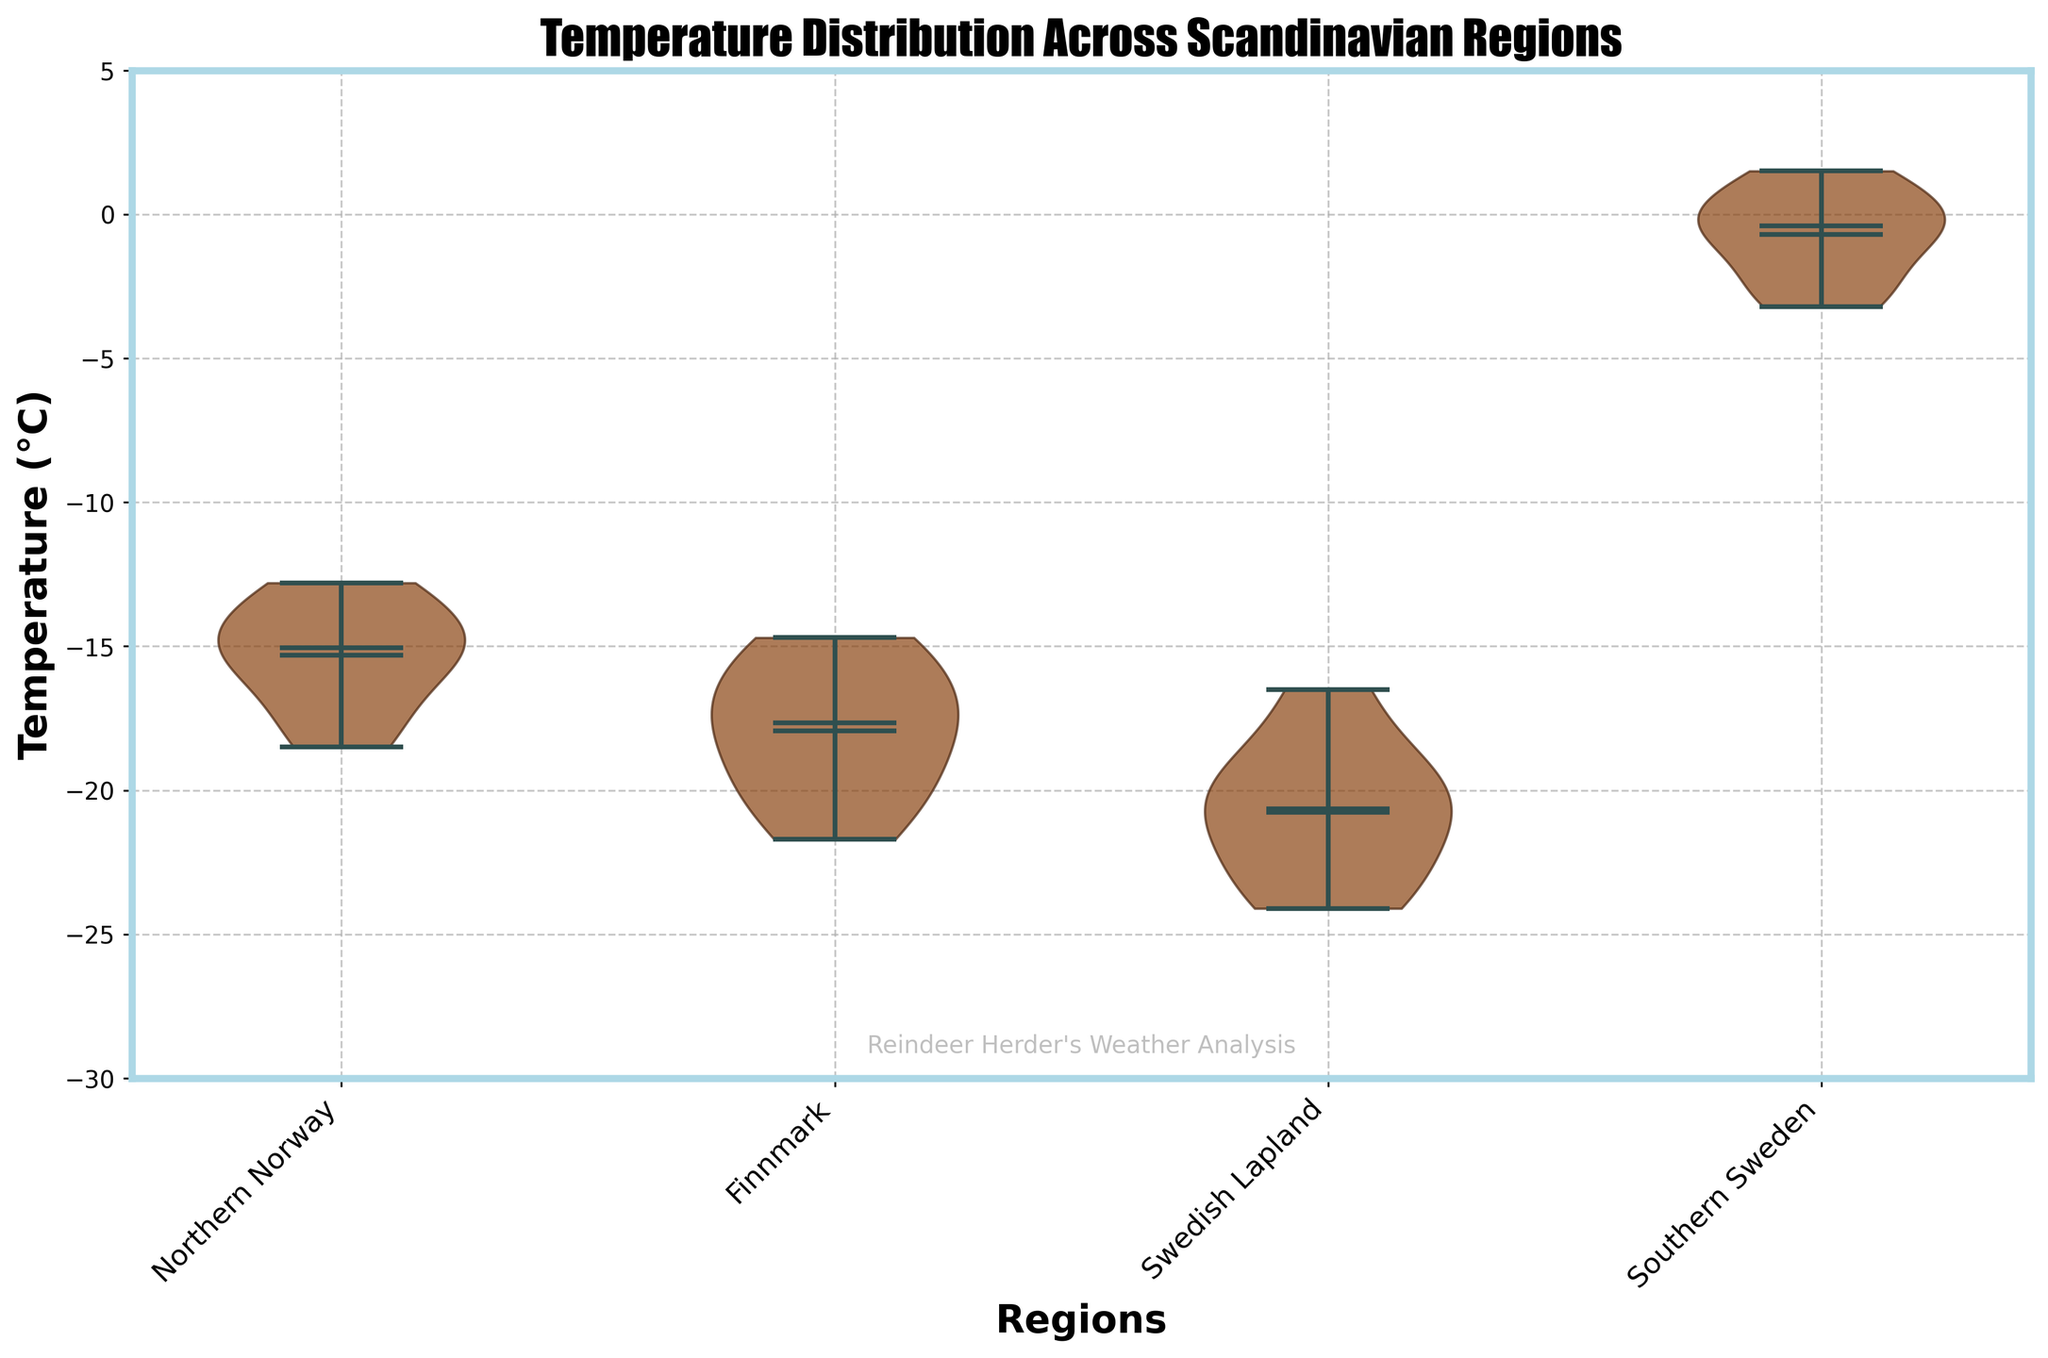what regions have data displayed in the plot? The x-axis labels show the different regions for which the temperature data is displayed. Those labels indicate the regions. The regions are Northern Norway, Finnmark, Swedish Lapland, and Southern Sweden.
Answer: Northern Norway, Finnmark, Swedish Lapland, and Southern Sweden What is the title of the plot? The title is displayed at the top of the plot. It summarizes the content of the plot, which involves temperatures in different Scandinavian regions.
Answer: Temperature Distribution Across Scandinavian Regions What is the mean temperature for Northern Norway represented in the plot? The mean values are indicated by a dot in the center of each violin shape. Locate the corresponding mean within the violin for Northern Norway.
Answer: Around -15°C Which region has the widest spread of temperatures? The spread is indicated by the width of the violin plot. The region with the widest section in its violin plot has the widest temperature spread.
Answer: Swedish Lapland Which region experiences the highest median temperature? The median is indicated by the horizontal bar inside the violin plot. Check each region's median temperature and identify the highest one.
Answer: Southern Sweden What are the minimum and maximum temperatures recorded in Finnmark? The minimum and maximum temperatures are indicated by the lower and upper extremes of the violin plot for Finnmark. Find these extremities for Finnmark.
Answer: Minimum: -21.7°C, Maximum: -14.7°C How do the median temperatures of Northern Norway and Finnmark compare? Compare the positions of the horizontal median bars in the violin plots for Northern Norway and Finnmark to see which is higher or if they are equal.
Answer: Northern Norway has a higher median temperature than Finnmark What effect does the plot use to indicate it is related to a cold climate, and what text is added as a watermark? The plot uses certain visual design elements to remind viewers of cold climates. The text watermark is added for context. Identify these features.
Answer: Frost effect on the plot edges; watermark text: 'Reindeer Herder's Weather Analysis' Which region appears to have the smallest variability in temperatures? Variability is shown by the width and shape of the violin plots. The region with the narrowest and most compact violin plot has the smallest temperature variability.
Answer: Southern Sweden Looking at Swedish Lapland, what is the difference between the maximum and minimum temperatures recorded? Calculate the difference between the upper and lower extremes of the violin plot for Swedish Lapland.
Answer: Difference: 24.1°C - 16.5°C = 7.6°C 